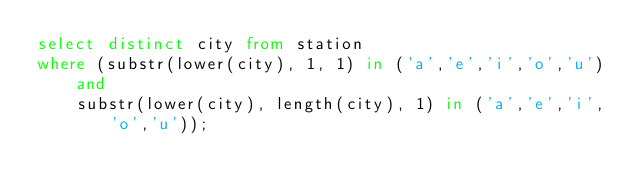Convert code to text. <code><loc_0><loc_0><loc_500><loc_500><_SQL_>select distinct city from station
where (substr(lower(city), 1, 1) in ('a','e','i','o','u')
    and
    substr(lower(city), length(city), 1) in ('a','e','i','o','u'));
</code> 